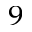Convert formula to latex. <formula><loc_0><loc_0><loc_500><loc_500>_ { 9 }</formula> 